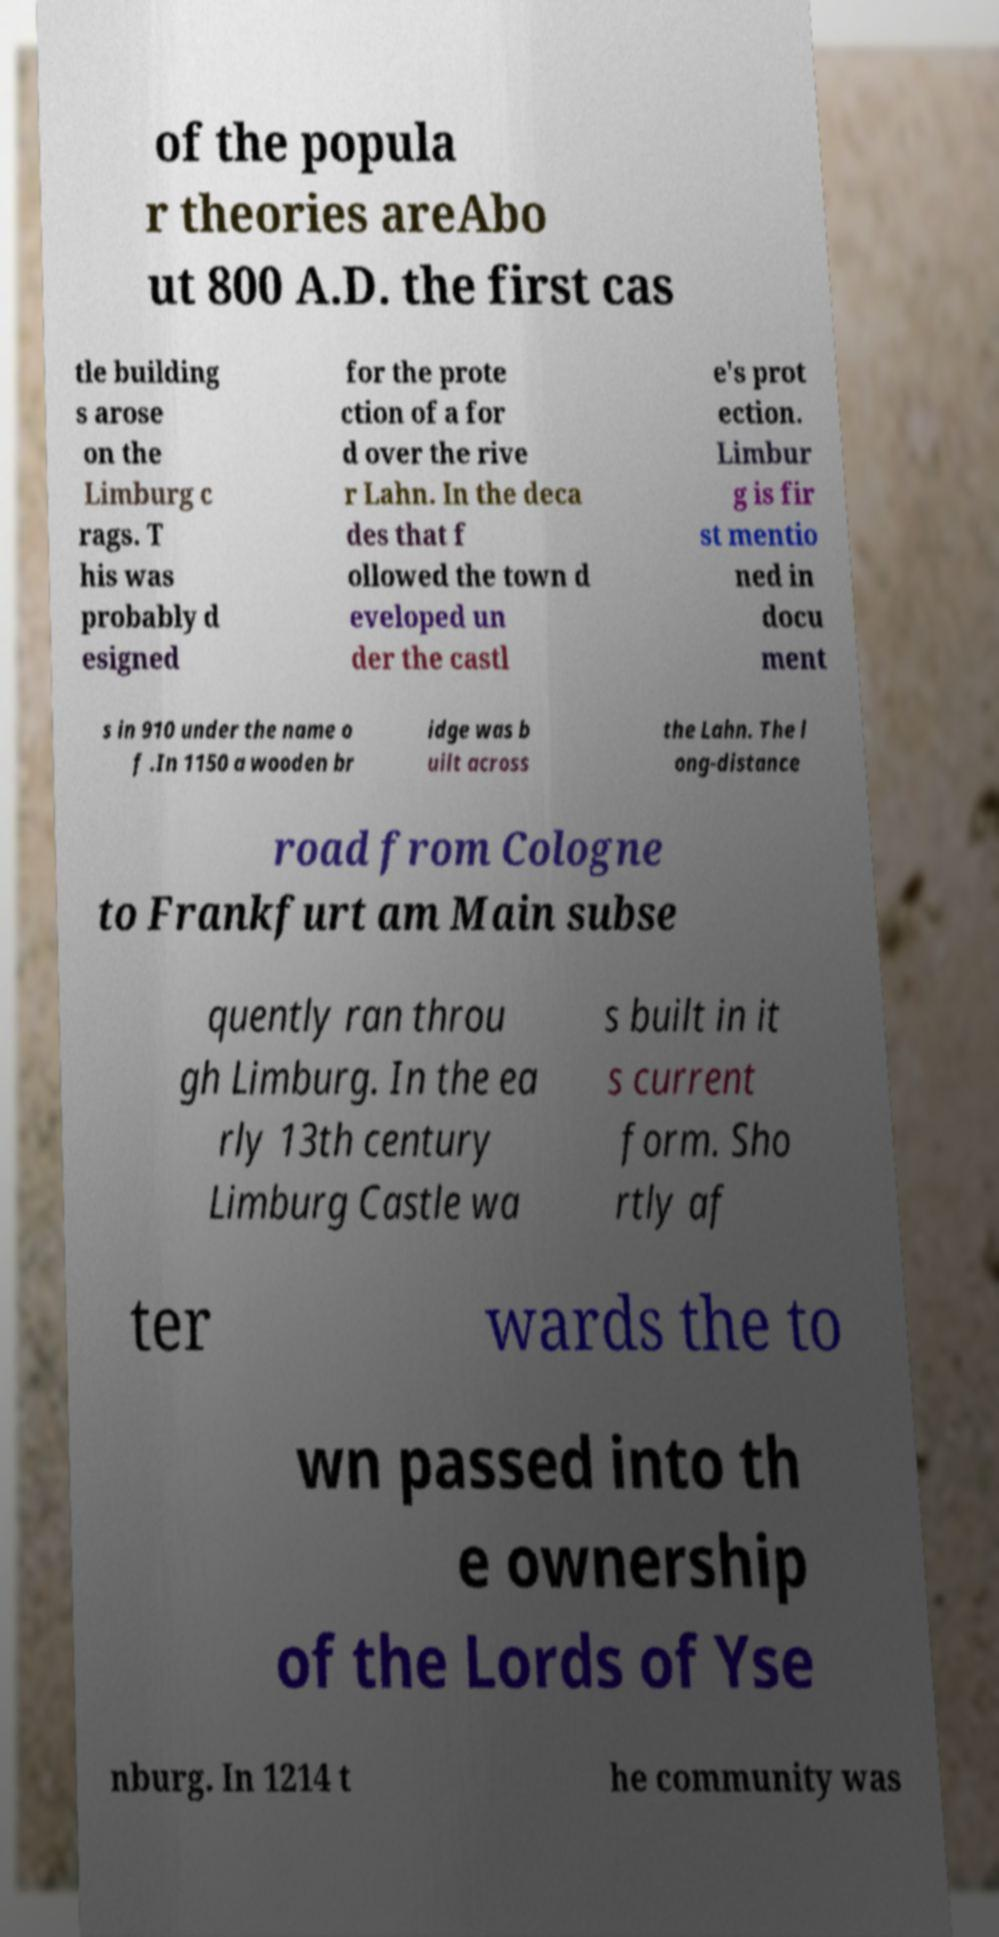Please identify and transcribe the text found in this image. of the popula r theories areAbo ut 800 A.D. the first cas tle building s arose on the Limburg c rags. T his was probably d esigned for the prote ction of a for d over the rive r Lahn. In the deca des that f ollowed the town d eveloped un der the castl e's prot ection. Limbur g is fir st mentio ned in docu ment s in 910 under the name o f .In 1150 a wooden br idge was b uilt across the Lahn. The l ong-distance road from Cologne to Frankfurt am Main subse quently ran throu gh Limburg. In the ea rly 13th century Limburg Castle wa s built in it s current form. Sho rtly af ter wards the to wn passed into th e ownership of the Lords of Yse nburg. In 1214 t he community was 